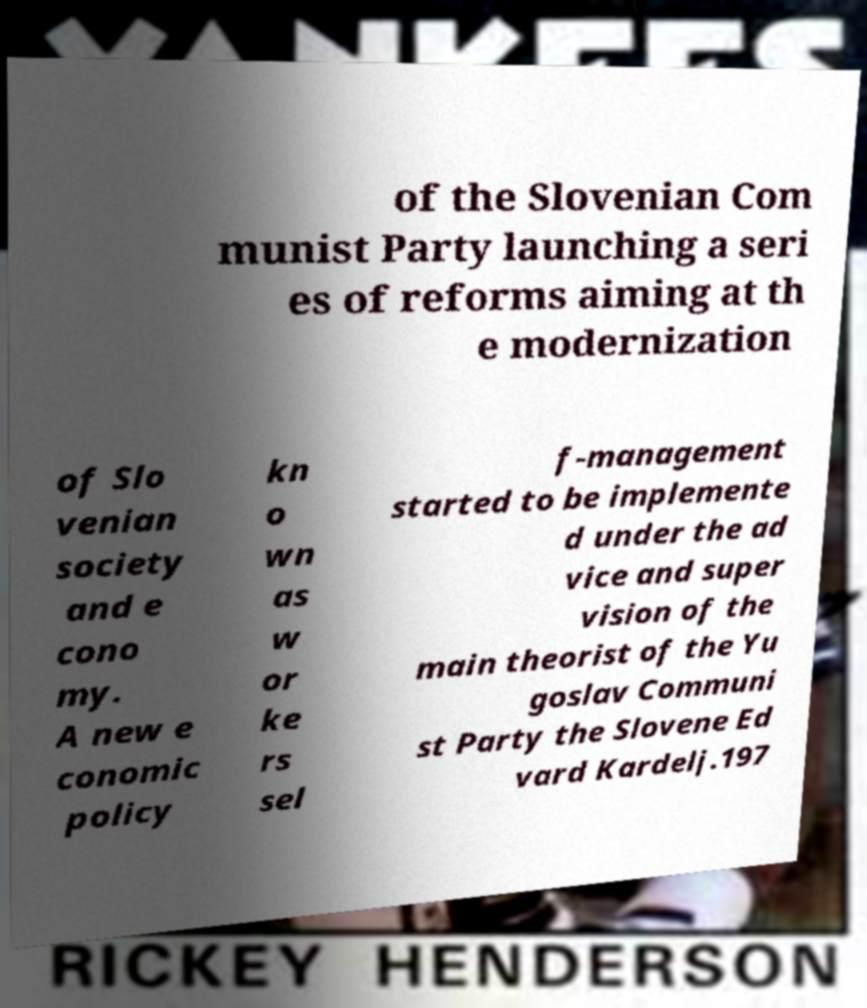What messages or text are displayed in this image? I need them in a readable, typed format. of the Slovenian Com munist Party launching a seri es of reforms aiming at th e modernization of Slo venian society and e cono my. A new e conomic policy kn o wn as w or ke rs sel f-management started to be implemente d under the ad vice and super vision of the main theorist of the Yu goslav Communi st Party the Slovene Ed vard Kardelj.197 